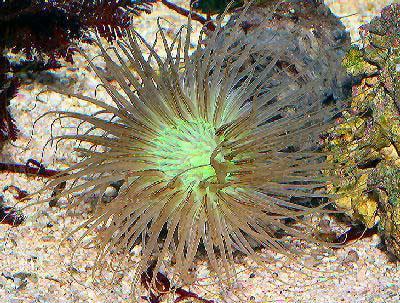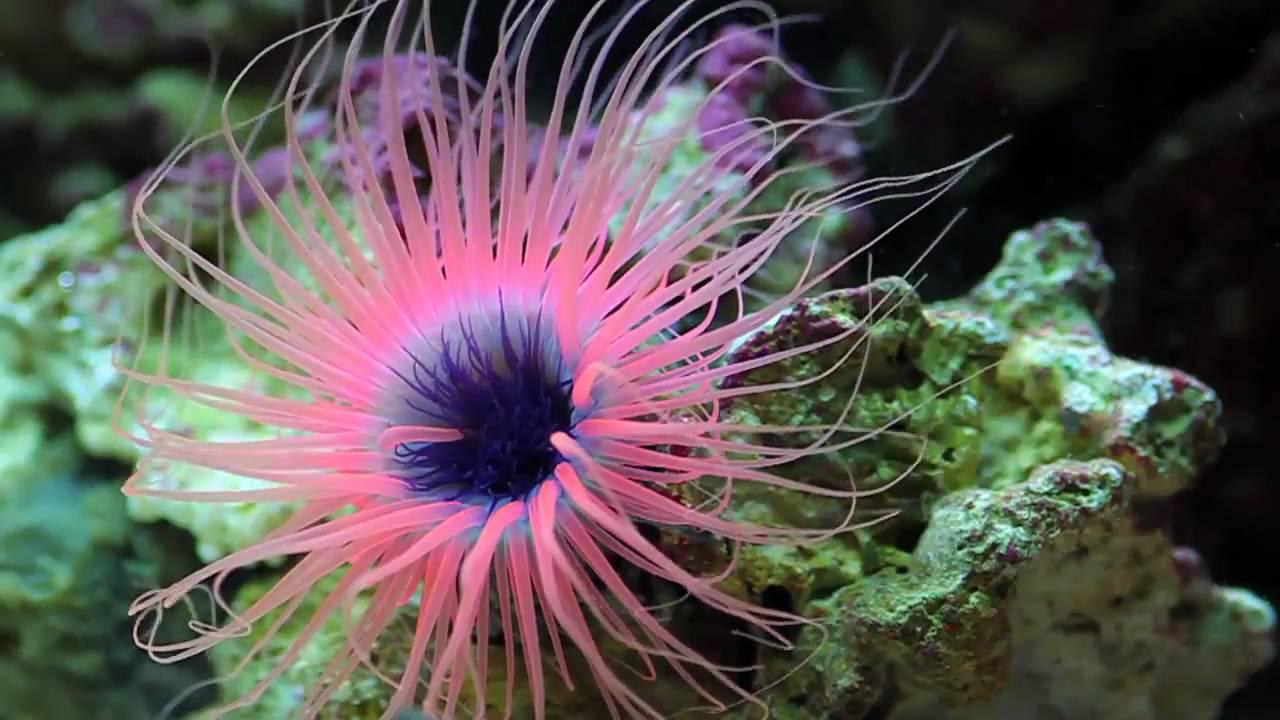The first image is the image on the left, the second image is the image on the right. Examine the images to the left and right. Is the description "Each image contains at least one prominent anemone with glowing bluish tint, but the lefthand anemone has a white center and deeper blue around the edges." accurate? Answer yes or no. No. 